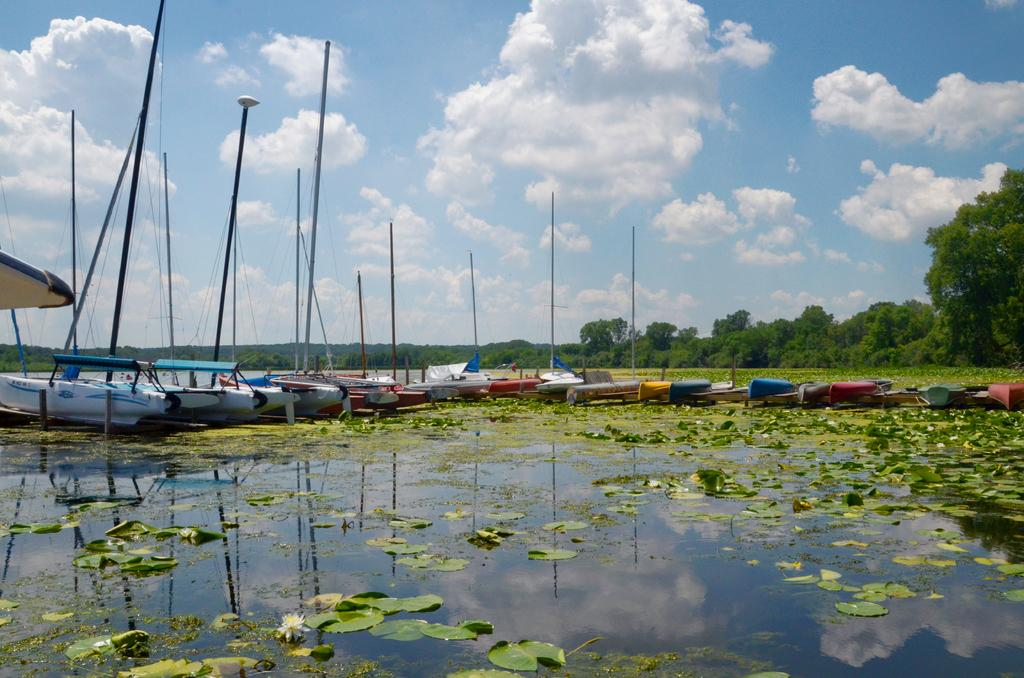What type of plants are in the image? There are lotus in the image. What else can be seen in the image besides the lotus? There are leaves and water visible in the image. What is located in the middle of the image? There are boats in the middle of the image. What can be seen in the background of the image? There are trees and sky visible in the background of the image. What is present in the sky in the background of the image? There are clouds in the background of the image. What type of camera can be seen in the image? There is no camera present in the image. Can you tell me where the zoo is located in the image? There is no zoo present in the image. 